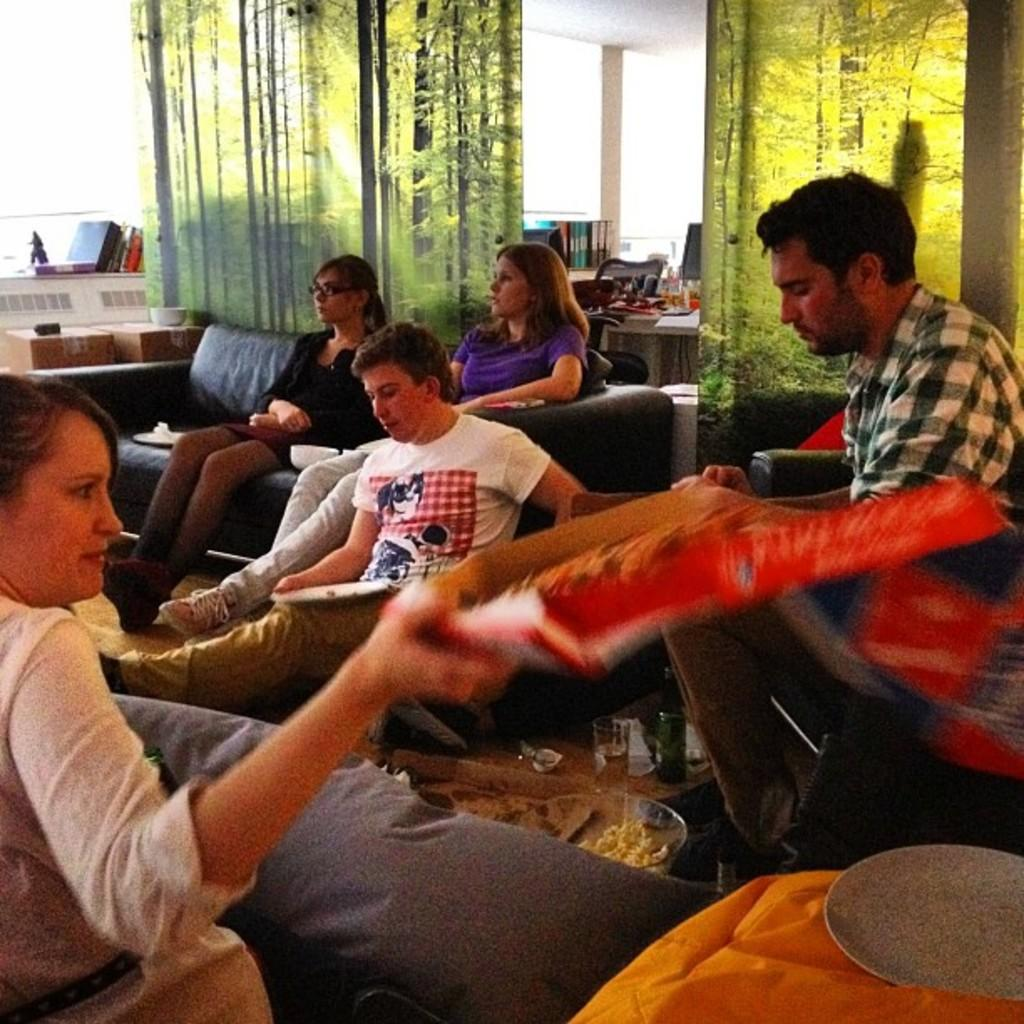What are the people in the image doing? There is a group of people sitting on a sofa in the image. What objects are in front of the sofa? There is a glass and a wine bottle in front of the sofa. What can be seen on the table in the image? There are books on a table in the image. What type of air can be seen in the image? There is no air visible in the image; it is a solid object, such as a sofa, glass, wine bottle, and books. Are there any balloons or toys present in the image? No, there are no balloons or toys present in the image. 